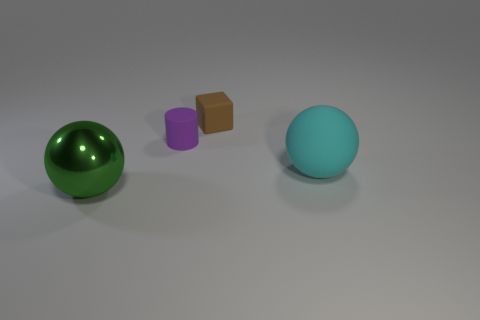What number of objects are both behind the cyan rubber ball and on the left side of the brown matte cube?
Make the answer very short. 1. What is the color of the large rubber object?
Your response must be concise. Cyan. What material is the other object that is the same shape as the green shiny thing?
Make the answer very short. Rubber. Are there any other things that have the same material as the big green sphere?
Give a very brief answer. No. Is the color of the matte cylinder the same as the large rubber ball?
Provide a short and direct response. No. There is a large object behind the big thing that is to the left of the brown rubber cube; what is its shape?
Your answer should be compact. Sphere. What shape is the purple thing that is the same material as the large cyan object?
Your answer should be compact. Cylinder. What number of other objects are there of the same shape as the brown rubber thing?
Your response must be concise. 0. Does the matte block that is behind the rubber ball have the same size as the large green metallic thing?
Your answer should be compact. No. Is the number of tiny objects in front of the large metal sphere greater than the number of small brown metal spheres?
Your response must be concise. No. 